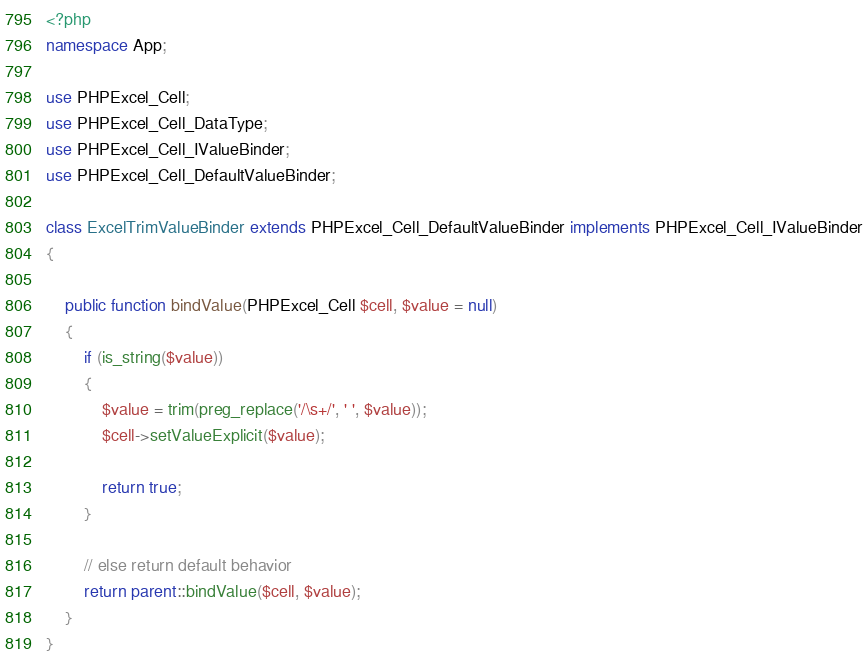<code> <loc_0><loc_0><loc_500><loc_500><_PHP_><?php
namespace App;

use PHPExcel_Cell;
use PHPExcel_Cell_DataType;
use PHPExcel_Cell_IValueBinder;
use PHPExcel_Cell_DefaultValueBinder;

class ExcelTrimValueBinder extends PHPExcel_Cell_DefaultValueBinder implements PHPExcel_Cell_IValueBinder
{
    
    public function bindValue(PHPExcel_Cell $cell, $value = null)
    {
        if (is_string($value))
        {
            $value = trim(preg_replace('/\s+/', ' ', $value));
            $cell->setValueExplicit($value);

            return true;
        }

        // else return default behavior
        return parent::bindValue($cell, $value);
    }
}
</code> 